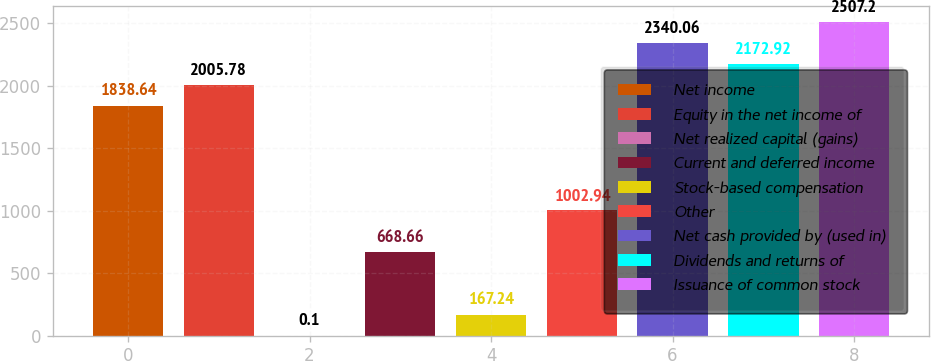Convert chart to OTSL. <chart><loc_0><loc_0><loc_500><loc_500><bar_chart><fcel>Net income<fcel>Equity in the net income of<fcel>Net realized capital (gains)<fcel>Current and deferred income<fcel>Stock-based compensation<fcel>Other<fcel>Net cash provided by (used in)<fcel>Dividends and returns of<fcel>Issuance of common stock<nl><fcel>1838.64<fcel>2005.78<fcel>0.1<fcel>668.66<fcel>167.24<fcel>1002.94<fcel>2340.06<fcel>2172.92<fcel>2507.2<nl></chart> 